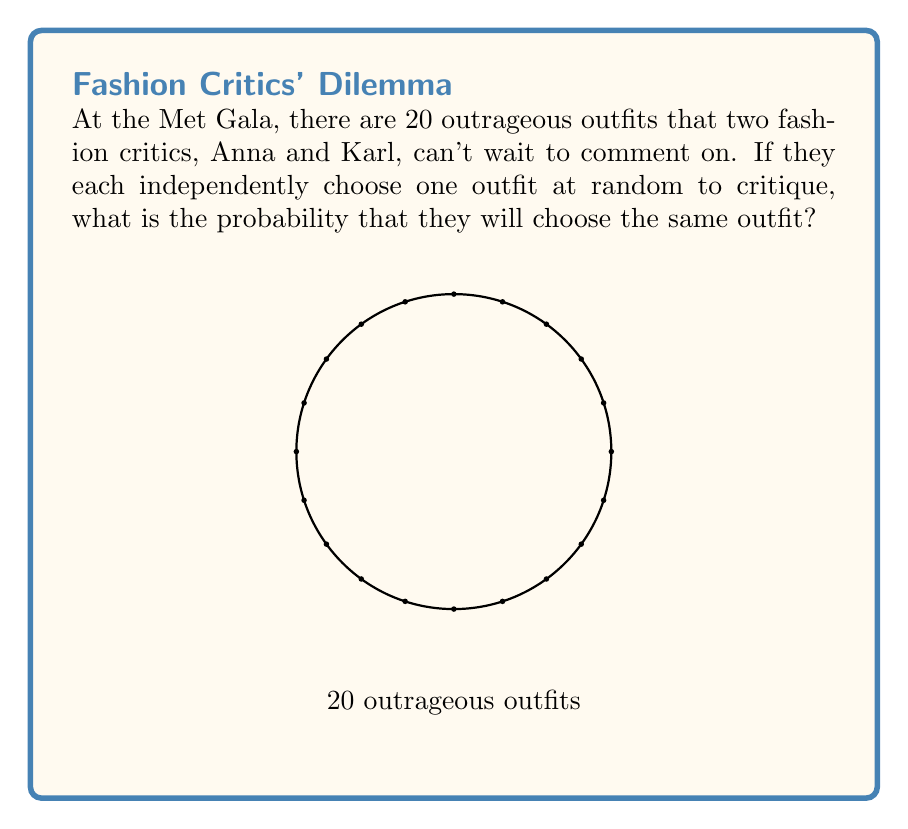Can you answer this question? Let's approach this step-by-step:

1) First, we need to understand what we're calculating. We want the probability that Anna and Karl choose the same outfit out of 20 options.

2) For this to happen, Karl needs to choose the same outfit that Anna chose. We can think of this as a two-step process:

   a) Anna chooses an outfit (any outfit).
   b) Karl chooses the same outfit as Anna.

3) The probability of Anna choosing any particular outfit is $\frac{1}{20}$, as there are 20 outfits to choose from.

4) Once Anna has chosen, for Karl to choose the same outfit, he must select that specific outfit out of the 20 available. The probability of this is also $\frac{1}{20}$.

5) Since these events are independent (Karl's choice doesn't depend on Anna's), we multiply these probabilities:

   $$P(\text{same outfit}) = \frac{1}{20} \times \frac{1}{20} = \frac{1}{400}$$

6) We can also think about this in terms of the total number of possible outcomes. There are 20 choices for Anna and 20 for Karl, so there are $20 \times 20 = 400$ total possible combinations of their choices. Only 20 of these combinations have them choosing the same outfit.

   $$P(\text{same outfit}) = \frac{\text{favorable outcomes}}{\text{total outcomes}} = \frac{20}{400} = \frac{1}{20}$$

Both methods lead to the same result.
Answer: $\frac{1}{20}$ or 0.05 or 5% 